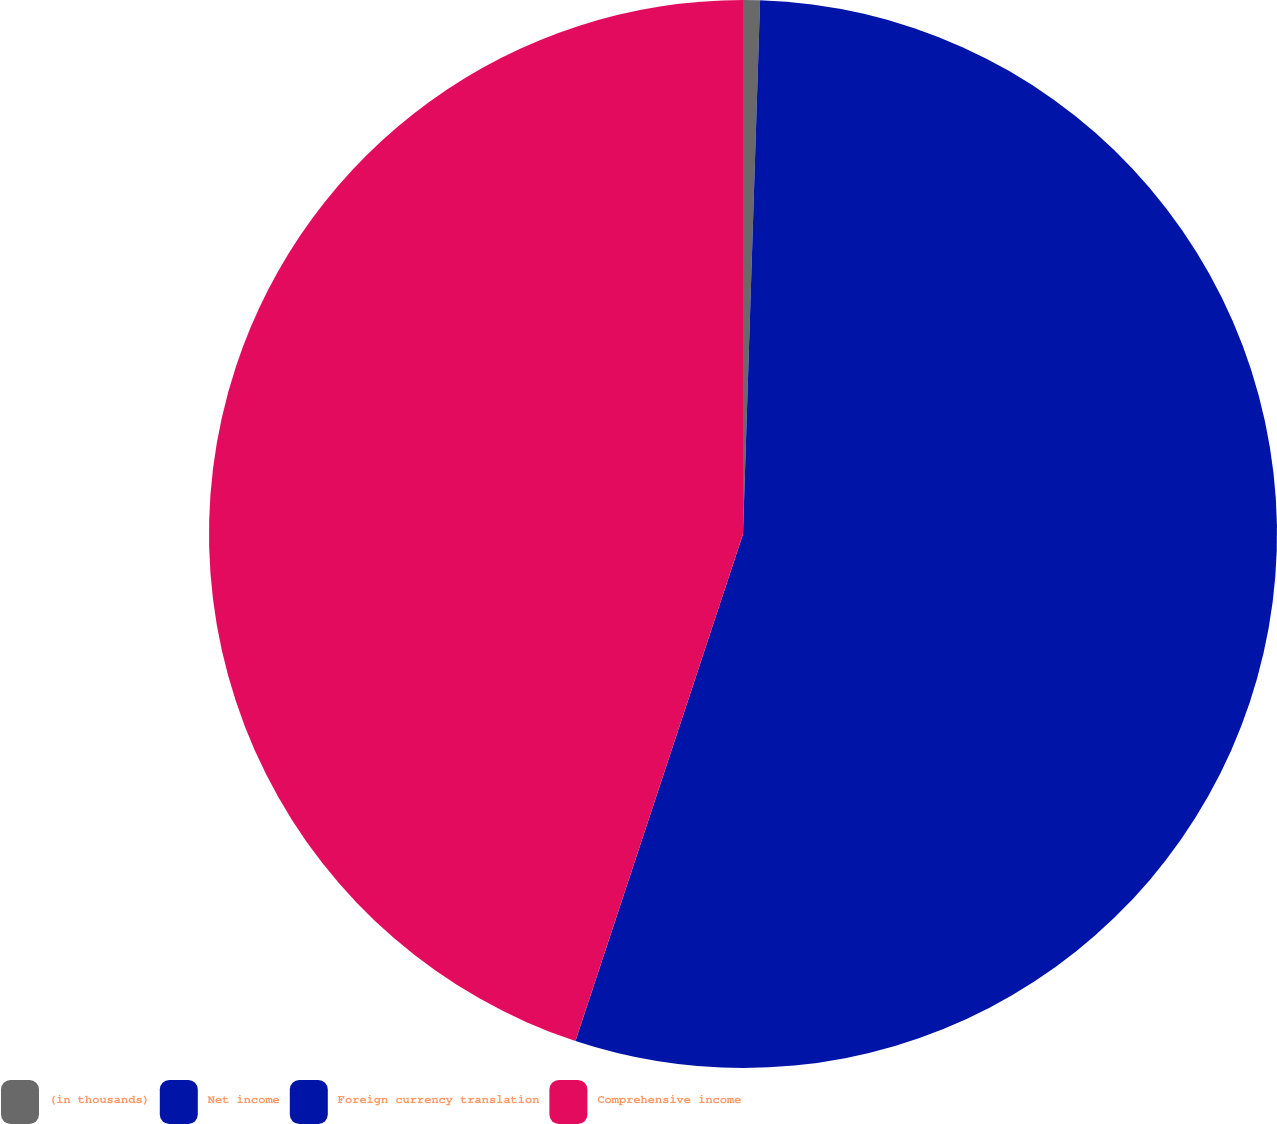Convert chart. <chart><loc_0><loc_0><loc_500><loc_500><pie_chart><fcel>(in thousands)<fcel>Net income<fcel>Foreign currency translation<fcel>Comprehensive income<nl><fcel>0.51%<fcel>49.49%<fcel>5.08%<fcel>44.92%<nl></chart> 